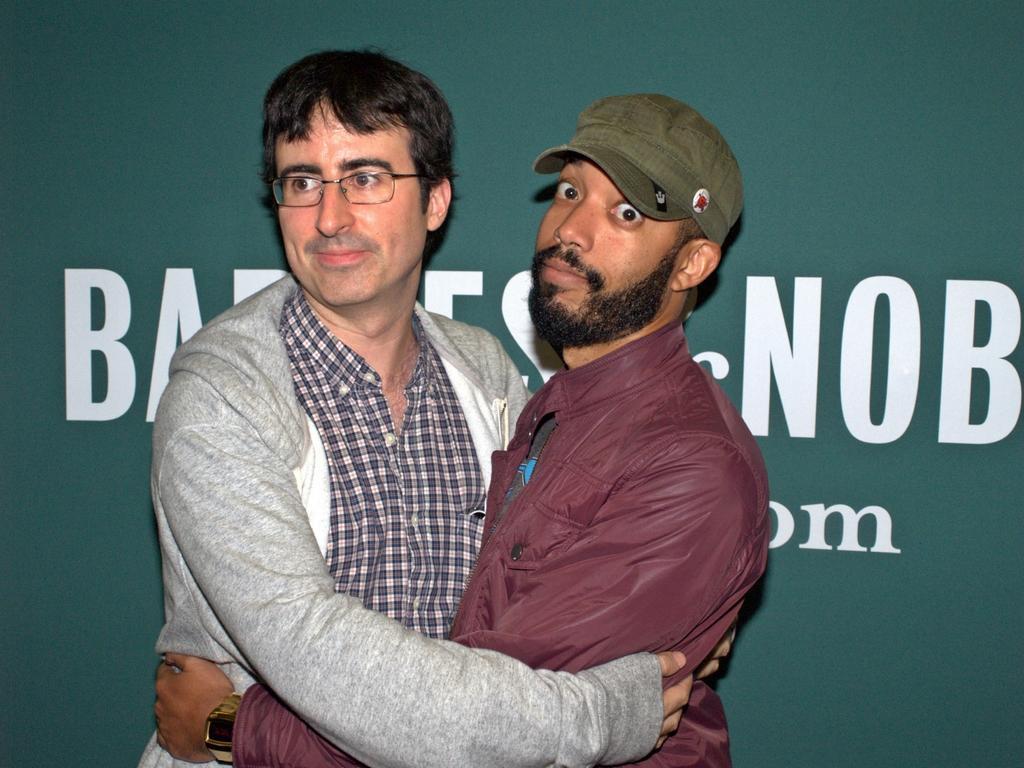Could you give a brief overview of what you see in this image? In the image two persons are standing and hugging. Behind them we can see a banner. 